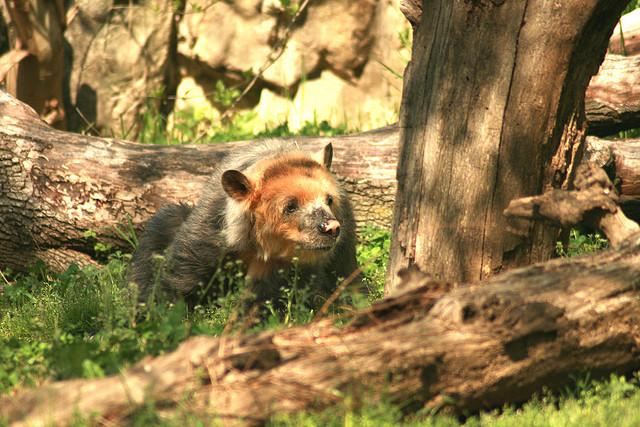Is this bear sitting in a tree?
Answer briefly. No. Does the animal look ferocious?
Be succinct. Yes. Is this animal known for liking honey?
Be succinct. Yes. 